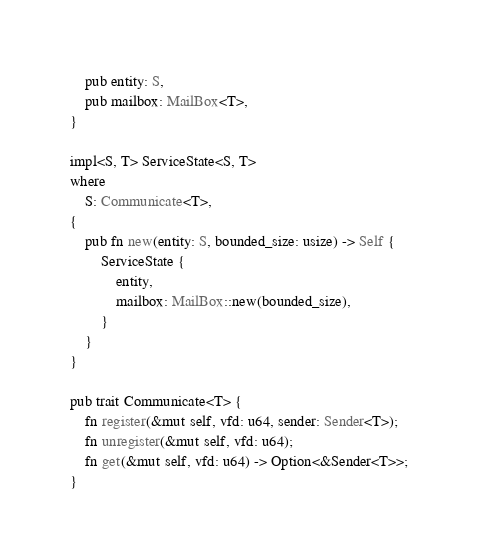<code> <loc_0><loc_0><loc_500><loc_500><_Rust_>    pub entity: S,
    pub mailbox: MailBox<T>,
}

impl<S, T> ServiceState<S, T>
where
    S: Communicate<T>,
{
    pub fn new(entity: S, bounded_size: usize) -> Self {
        ServiceState {
            entity,
            mailbox: MailBox::new(bounded_size),
        }
    }
}

pub trait Communicate<T> {
    fn register(&mut self, vfd: u64, sender: Sender<T>);
    fn unregister(&mut self, vfd: u64);
    fn get(&mut self, vfd: u64) -> Option<&Sender<T>>;
}
</code> 